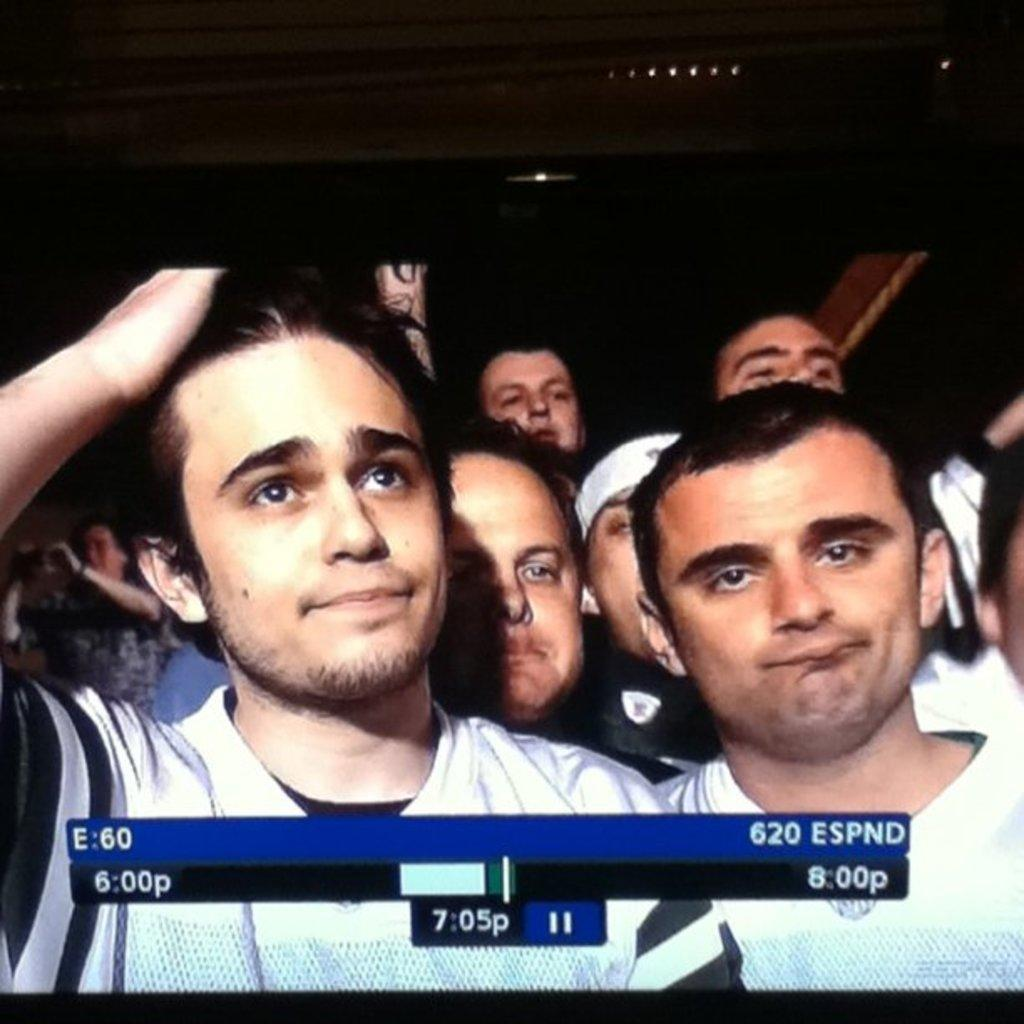How many people are in the image? The number of people in the image cannot be determined from the provided fact. What type of spiders can be seen crawling on the people in the image? There is no mention of spiders or any crawling creatures in the image, so this cannot be answered definitively. 